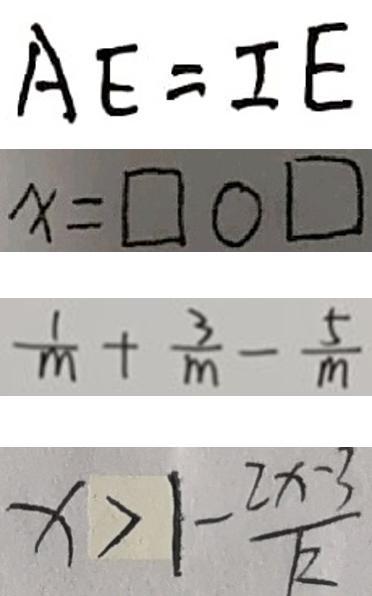Convert formula to latex. <formula><loc_0><loc_0><loc_500><loc_500>A E = I E 
 x = \square \bigcirc \square 
 \frac { 1 } { m } + \frac { 3 } { m } - \frac { 5 } { m } 
 x > 1 - \frac { 2 x - 3 } { k }</formula> 